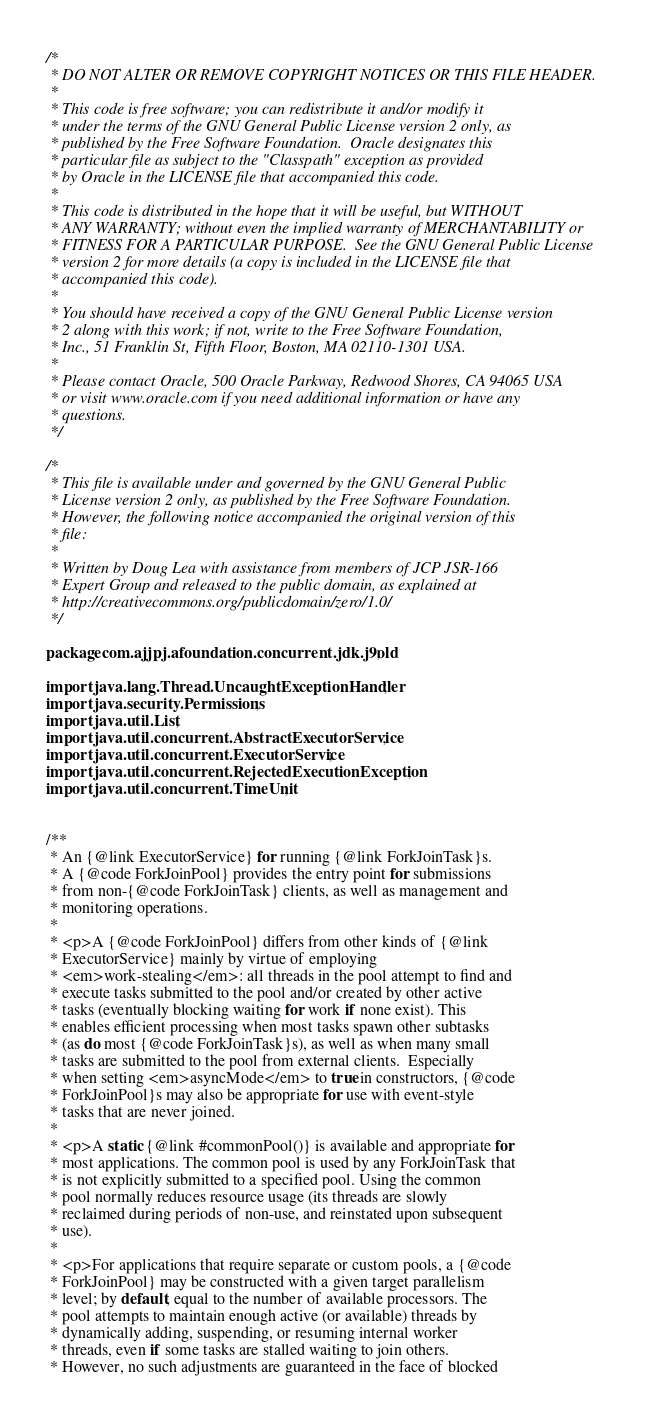Convert code to text. <code><loc_0><loc_0><loc_500><loc_500><_Java_>/*
 * DO NOT ALTER OR REMOVE COPYRIGHT NOTICES OR THIS FILE HEADER.
 *
 * This code is free software; you can redistribute it and/or modify it
 * under the terms of the GNU General Public License version 2 only, as
 * published by the Free Software Foundation.  Oracle designates this
 * particular file as subject to the "Classpath" exception as provided
 * by Oracle in the LICENSE file that accompanied this code.
 *
 * This code is distributed in the hope that it will be useful, but WITHOUT
 * ANY WARRANTY; without even the implied warranty of MERCHANTABILITY or
 * FITNESS FOR A PARTICULAR PURPOSE.  See the GNU General Public License
 * version 2 for more details (a copy is included in the LICENSE file that
 * accompanied this code).
 *
 * You should have received a copy of the GNU General Public License version
 * 2 along with this work; if not, write to the Free Software Foundation,
 * Inc., 51 Franklin St, Fifth Floor, Boston, MA 02110-1301 USA.
 *
 * Please contact Oracle, 500 Oracle Parkway, Redwood Shores, CA 94065 USA
 * or visit www.oracle.com if you need additional information or have any
 * questions.
 */

/*
 * This file is available under and governed by the GNU General Public
 * License version 2 only, as published by the Free Software Foundation.
 * However, the following notice accompanied the original version of this
 * file:
 *
 * Written by Doug Lea with assistance from members of JCP JSR-166
 * Expert Group and released to the public domain, as explained at
 * http://creativecommons.org/publicdomain/zero/1.0/
 */

package com.ajjpj.afoundation.concurrent.jdk.j9old;

import java.lang.Thread.UncaughtExceptionHandler;
import java.security.Permissions;
import java.util.List;
import java.util.concurrent.AbstractExecutorService;
import java.util.concurrent.ExecutorService;
import java.util.concurrent.RejectedExecutionException;
import java.util.concurrent.TimeUnit;


/**
 * An {@link ExecutorService} for running {@link ForkJoinTask}s.
 * A {@code ForkJoinPool} provides the entry point for submissions
 * from non-{@code ForkJoinTask} clients, as well as management and
 * monitoring operations.
 *
 * <p>A {@code ForkJoinPool} differs from other kinds of {@link
 * ExecutorService} mainly by virtue of employing
 * <em>work-stealing</em>: all threads in the pool attempt to find and
 * execute tasks submitted to the pool and/or created by other active
 * tasks (eventually blocking waiting for work if none exist). This
 * enables efficient processing when most tasks spawn other subtasks
 * (as do most {@code ForkJoinTask}s), as well as when many small
 * tasks are submitted to the pool from external clients.  Especially
 * when setting <em>asyncMode</em> to true in constructors, {@code
 * ForkJoinPool}s may also be appropriate for use with event-style
 * tasks that are never joined.
 *
 * <p>A static {@link #commonPool()} is available and appropriate for
 * most applications. The common pool is used by any ForkJoinTask that
 * is not explicitly submitted to a specified pool. Using the common
 * pool normally reduces resource usage (its threads are slowly
 * reclaimed during periods of non-use, and reinstated upon subsequent
 * use).
 *
 * <p>For applications that require separate or custom pools, a {@code
 * ForkJoinPool} may be constructed with a given target parallelism
 * level; by default, equal to the number of available processors. The
 * pool attempts to maintain enough active (or available) threads by
 * dynamically adding, suspending, or resuming internal worker
 * threads, even if some tasks are stalled waiting to join others.
 * However, no such adjustments are guaranteed in the face of blocked</code> 